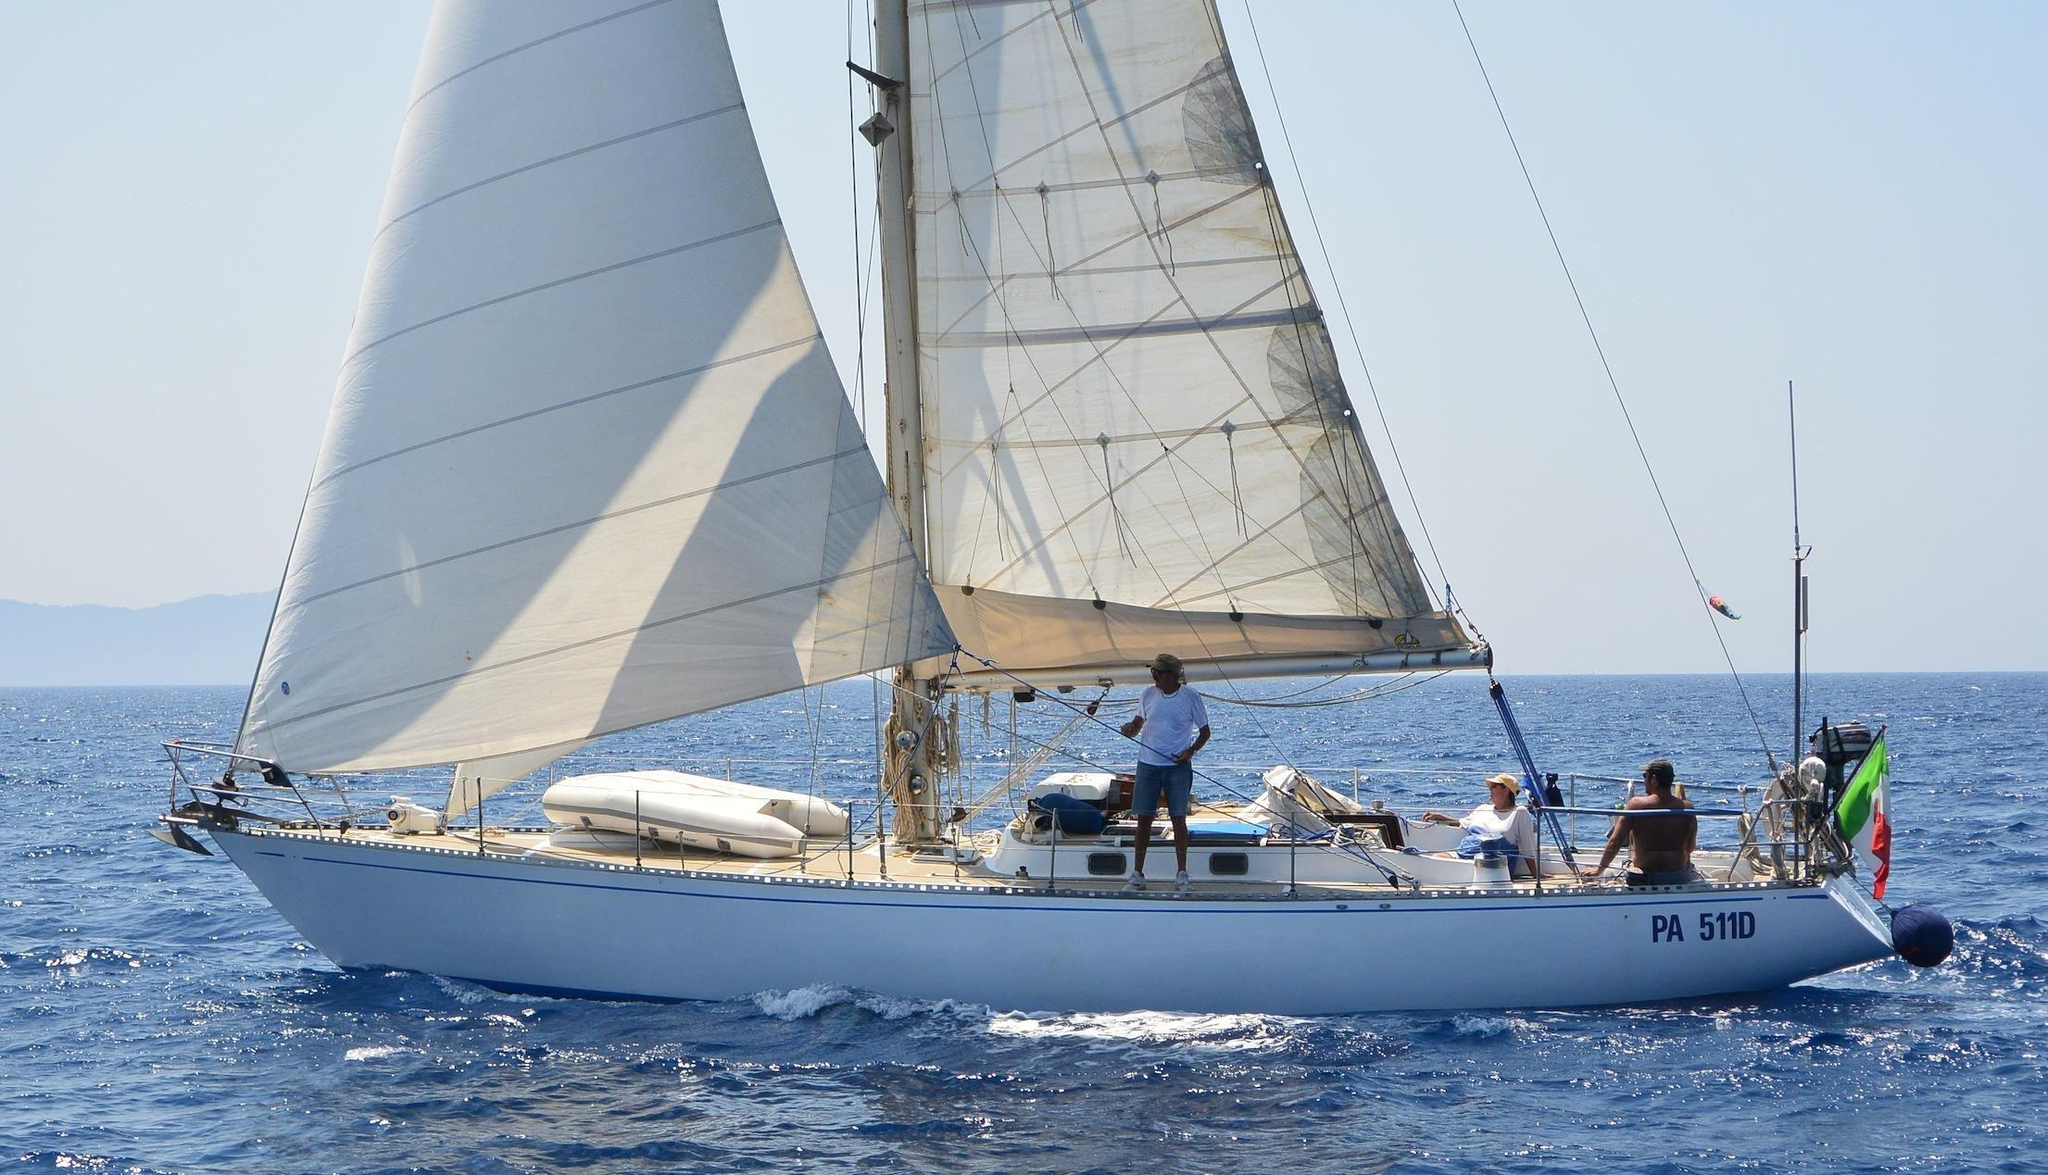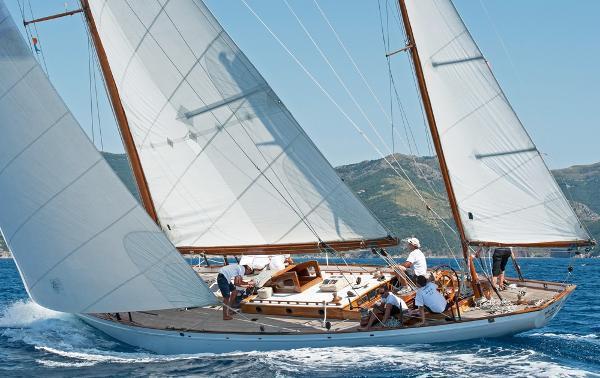The first image is the image on the left, the second image is the image on the right. Analyze the images presented: Is the assertion "Hilly land is visible behind one of the boats." valid? Answer yes or no. Yes. 